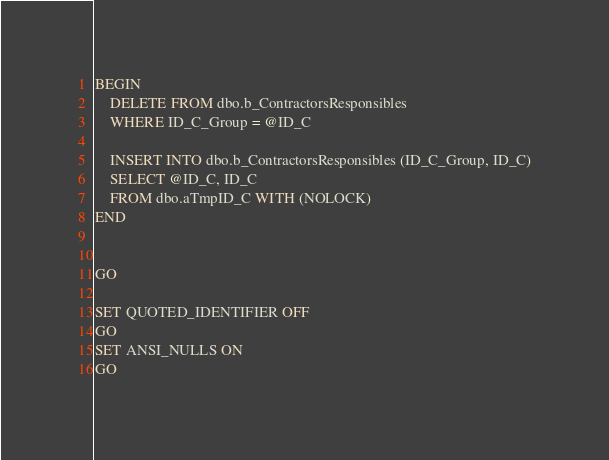Convert code to text. <code><loc_0><loc_0><loc_500><loc_500><_SQL_>BEGIN
    DELETE FROM dbo.b_ContractorsResponsibles
	WHERE ID_C_Group = @ID_C
	
	INSERT INTO dbo.b_ContractorsResponsibles (ID_C_Group, ID_C)
	SELECT @ID_C, ID_C
	FROM dbo.aTmpID_C WITH (NOLOCK)
END


GO

SET QUOTED_IDENTIFIER OFF 
GO
SET ANSI_NULLS ON 
GO
</code> 